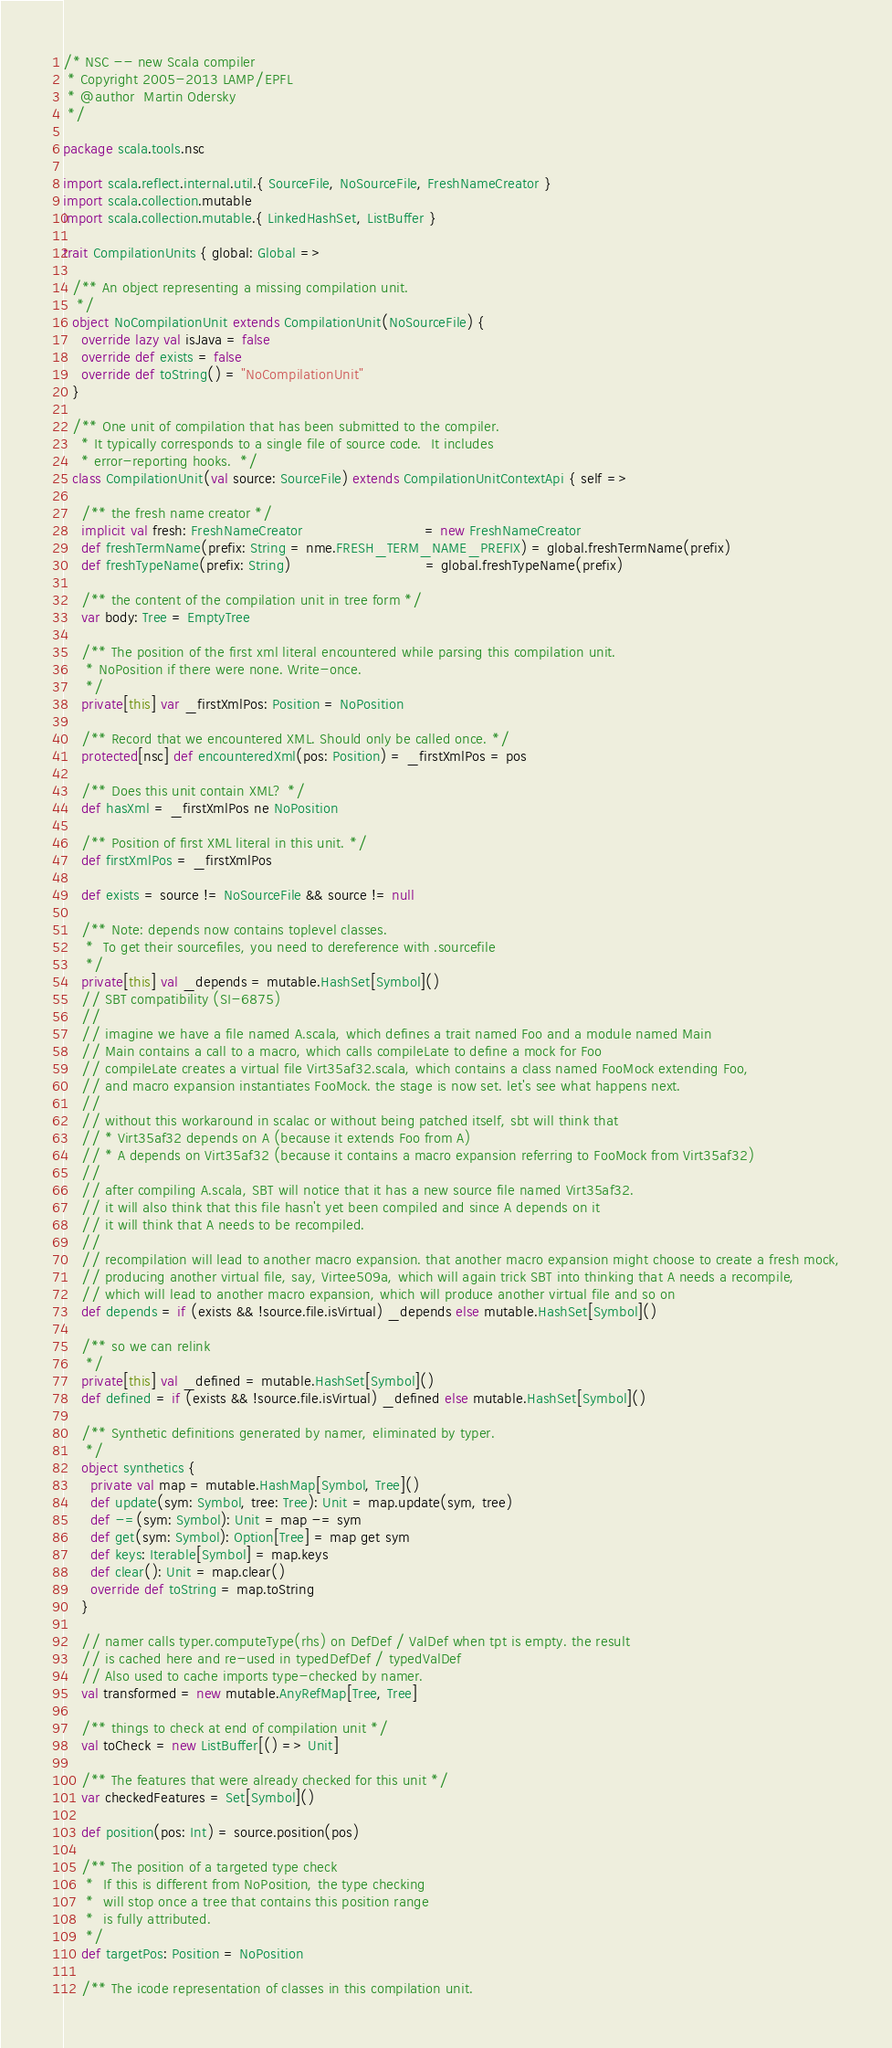<code> <loc_0><loc_0><loc_500><loc_500><_Scala_>/* NSC -- new Scala compiler
 * Copyright 2005-2013 LAMP/EPFL
 * @author  Martin Odersky
 */

package scala.tools.nsc

import scala.reflect.internal.util.{ SourceFile, NoSourceFile, FreshNameCreator }
import scala.collection.mutable
import scala.collection.mutable.{ LinkedHashSet, ListBuffer }

trait CompilationUnits { global: Global =>

  /** An object representing a missing compilation unit.
   */
  object NoCompilationUnit extends CompilationUnit(NoSourceFile) {
    override lazy val isJava = false
    override def exists = false
    override def toString() = "NoCompilationUnit"
  }

  /** One unit of compilation that has been submitted to the compiler.
    * It typically corresponds to a single file of source code.  It includes
    * error-reporting hooks.  */
  class CompilationUnit(val source: SourceFile) extends CompilationUnitContextApi { self =>

    /** the fresh name creator */
    implicit val fresh: FreshNameCreator                           = new FreshNameCreator
    def freshTermName(prefix: String = nme.FRESH_TERM_NAME_PREFIX) = global.freshTermName(prefix)
    def freshTypeName(prefix: String)                              = global.freshTypeName(prefix)

    /** the content of the compilation unit in tree form */
    var body: Tree = EmptyTree

    /** The position of the first xml literal encountered while parsing this compilation unit.
     * NoPosition if there were none. Write-once.
     */
    private[this] var _firstXmlPos: Position = NoPosition

    /** Record that we encountered XML. Should only be called once. */
    protected[nsc] def encounteredXml(pos: Position) = _firstXmlPos = pos

    /** Does this unit contain XML? */
    def hasXml = _firstXmlPos ne NoPosition

    /** Position of first XML literal in this unit. */
    def firstXmlPos = _firstXmlPos

    def exists = source != NoSourceFile && source != null

    /** Note: depends now contains toplevel classes.
     *  To get their sourcefiles, you need to dereference with .sourcefile
     */
    private[this] val _depends = mutable.HashSet[Symbol]()
    // SBT compatibility (SI-6875)
    //
    // imagine we have a file named A.scala, which defines a trait named Foo and a module named Main
    // Main contains a call to a macro, which calls compileLate to define a mock for Foo
    // compileLate creates a virtual file Virt35af32.scala, which contains a class named FooMock extending Foo,
    // and macro expansion instantiates FooMock. the stage is now set. let's see what happens next.
    //
    // without this workaround in scalac or without being patched itself, sbt will think that
    // * Virt35af32 depends on A (because it extends Foo from A)
    // * A depends on Virt35af32 (because it contains a macro expansion referring to FooMock from Virt35af32)
    //
    // after compiling A.scala, SBT will notice that it has a new source file named Virt35af32.
    // it will also think that this file hasn't yet been compiled and since A depends on it
    // it will think that A needs to be recompiled.
    //
    // recompilation will lead to another macro expansion. that another macro expansion might choose to create a fresh mock,
    // producing another virtual file, say, Virtee509a, which will again trick SBT into thinking that A needs a recompile,
    // which will lead to another macro expansion, which will produce another virtual file and so on
    def depends = if (exists && !source.file.isVirtual) _depends else mutable.HashSet[Symbol]()

    /** so we can relink
     */
    private[this] val _defined = mutable.HashSet[Symbol]()
    def defined = if (exists && !source.file.isVirtual) _defined else mutable.HashSet[Symbol]()

    /** Synthetic definitions generated by namer, eliminated by typer.
     */
    object synthetics {
      private val map = mutable.HashMap[Symbol, Tree]()
      def update(sym: Symbol, tree: Tree): Unit = map.update(sym, tree)
      def -=(sym: Symbol): Unit = map -= sym
      def get(sym: Symbol): Option[Tree] = map get sym
      def keys: Iterable[Symbol] = map.keys
      def clear(): Unit = map.clear()
      override def toString = map.toString
    }

    // namer calls typer.computeType(rhs) on DefDef / ValDef when tpt is empty. the result
    // is cached here and re-used in typedDefDef / typedValDef
    // Also used to cache imports type-checked by namer.
    val transformed = new mutable.AnyRefMap[Tree, Tree]

    /** things to check at end of compilation unit */
    val toCheck = new ListBuffer[() => Unit]

    /** The features that were already checked for this unit */
    var checkedFeatures = Set[Symbol]()

    def position(pos: Int) = source.position(pos)

    /** The position of a targeted type check
     *  If this is different from NoPosition, the type checking
     *  will stop once a tree that contains this position range
     *  is fully attributed.
     */
    def targetPos: Position = NoPosition

    /** The icode representation of classes in this compilation unit.</code> 